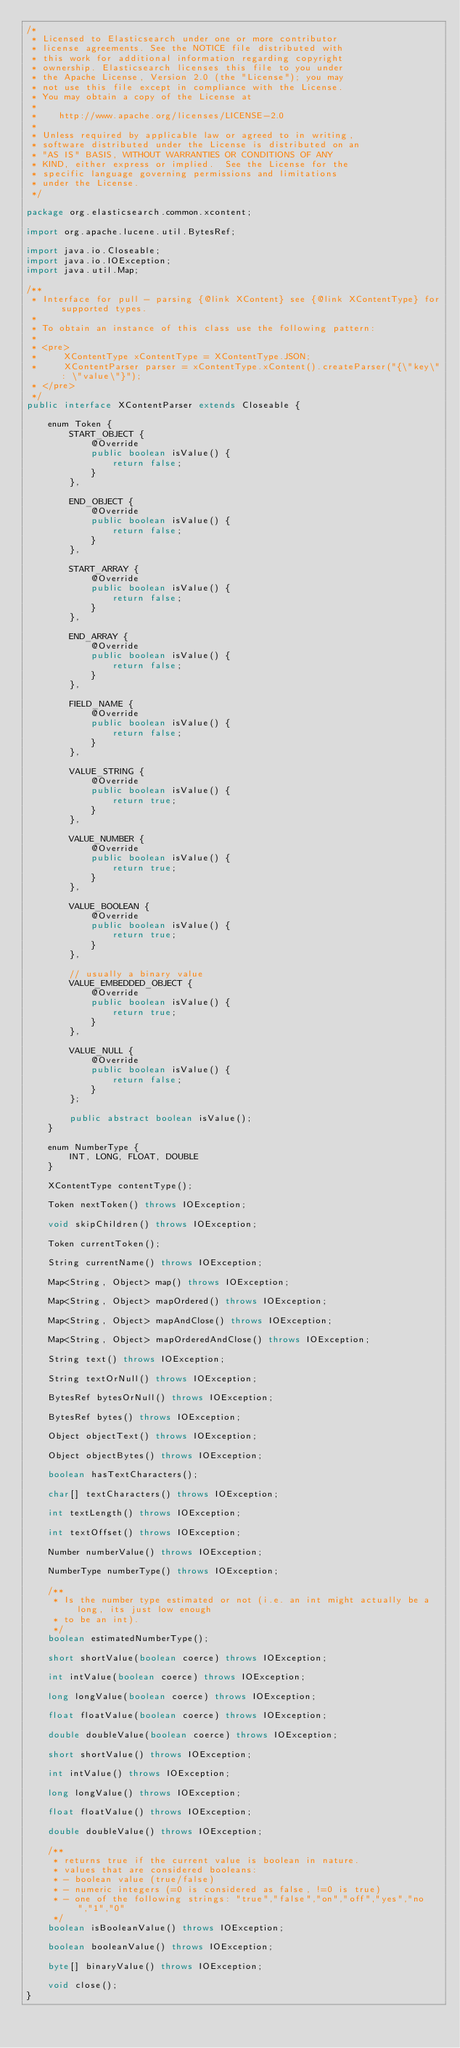<code> <loc_0><loc_0><loc_500><loc_500><_Java_>/*
 * Licensed to Elasticsearch under one or more contributor
 * license agreements. See the NOTICE file distributed with
 * this work for additional information regarding copyright
 * ownership. Elasticsearch licenses this file to you under
 * the Apache License, Version 2.0 (the "License"); you may
 * not use this file except in compliance with the License.
 * You may obtain a copy of the License at
 *
 *    http://www.apache.org/licenses/LICENSE-2.0
 *
 * Unless required by applicable law or agreed to in writing,
 * software distributed under the License is distributed on an
 * "AS IS" BASIS, WITHOUT WARRANTIES OR CONDITIONS OF ANY
 * KIND, either express or implied.  See the License for the
 * specific language governing permissions and limitations
 * under the License.
 */

package org.elasticsearch.common.xcontent;

import org.apache.lucene.util.BytesRef;

import java.io.Closeable;
import java.io.IOException;
import java.util.Map;

/**
 * Interface for pull - parsing {@link XContent} see {@link XContentType} for supported types.
 *
 * To obtain an instance of this class use the following pattern:
 *
 * <pre>
 *     XContentType xContentType = XContentType.JSON;
 *     XContentParser parser = xContentType.xContent().createParser("{\"key\" : \"value\"}");
 * </pre>
 */
public interface XContentParser extends Closeable {

    enum Token {
        START_OBJECT {
            @Override
            public boolean isValue() {
                return false;
            }
        },

        END_OBJECT {
            @Override
            public boolean isValue() {
                return false;
            }
        },

        START_ARRAY {
            @Override
            public boolean isValue() {
                return false;
            }
        },

        END_ARRAY {
            @Override
            public boolean isValue() {
                return false;
            }
        },

        FIELD_NAME {
            @Override
            public boolean isValue() {
                return false;
            }
        },

        VALUE_STRING {
            @Override
            public boolean isValue() {
                return true;
            }
        },

        VALUE_NUMBER {
            @Override
            public boolean isValue() {
                return true;
            }
        },

        VALUE_BOOLEAN {
            @Override
            public boolean isValue() {
                return true;
            }
        },

        // usually a binary value
        VALUE_EMBEDDED_OBJECT {
            @Override
            public boolean isValue() {
                return true;
            }
        },

        VALUE_NULL {
            @Override
            public boolean isValue() {
                return false;
            }
        };

        public abstract boolean isValue();
    }

    enum NumberType {
        INT, LONG, FLOAT, DOUBLE
    }

    XContentType contentType();

    Token nextToken() throws IOException;

    void skipChildren() throws IOException;

    Token currentToken();

    String currentName() throws IOException;

    Map<String, Object> map() throws IOException;

    Map<String, Object> mapOrdered() throws IOException;

    Map<String, Object> mapAndClose() throws IOException;

    Map<String, Object> mapOrderedAndClose() throws IOException;

    String text() throws IOException;

    String textOrNull() throws IOException;

    BytesRef bytesOrNull() throws IOException;

    BytesRef bytes() throws IOException;

    Object objectText() throws IOException;

    Object objectBytes() throws IOException;

    boolean hasTextCharacters();

    char[] textCharacters() throws IOException;

    int textLength() throws IOException;

    int textOffset() throws IOException;

    Number numberValue() throws IOException;

    NumberType numberType() throws IOException;

    /**
     * Is the number type estimated or not (i.e. an int might actually be a long, its just low enough
     * to be an int).
     */
    boolean estimatedNumberType();

    short shortValue(boolean coerce) throws IOException;

    int intValue(boolean coerce) throws IOException;

    long longValue(boolean coerce) throws IOException;

    float floatValue(boolean coerce) throws IOException;

    double doubleValue(boolean coerce) throws IOException;
    
    short shortValue() throws IOException;

    int intValue() throws IOException;

    long longValue() throws IOException;

    float floatValue() throws IOException;

    double doubleValue() throws IOException;

    /**
     * returns true if the current value is boolean in nature.
     * values that are considered booleans:
     * - boolean value (true/false)
     * - numeric integers (=0 is considered as false, !=0 is true)
     * - one of the following strings: "true","false","on","off","yes","no","1","0"
     */
    boolean isBooleanValue() throws IOException;

    boolean booleanValue() throws IOException;

    byte[] binaryValue() throws IOException;

    void close();
}
</code> 